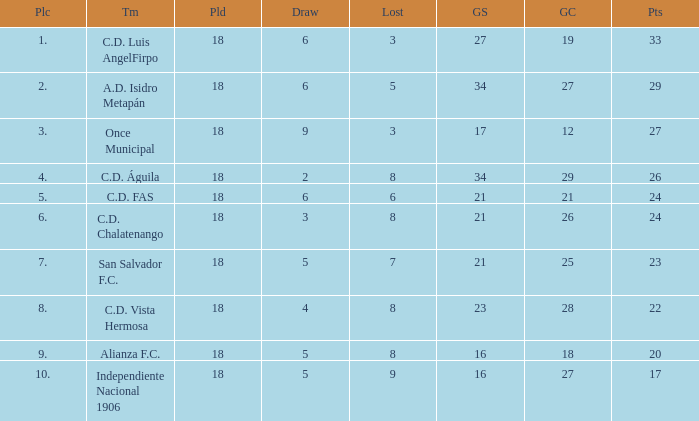What were the goal conceded that had a lost greater than 8 and more than 17 points? None. 